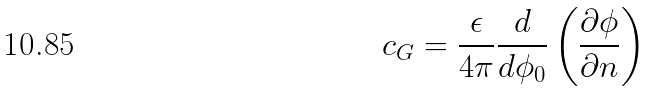Convert formula to latex. <formula><loc_0><loc_0><loc_500><loc_500>c _ { G } = \frac { \epsilon } { 4 \pi } \frac { d } { d \phi _ { 0 } } \left ( \frac { \partial \phi } { \partial n } \right )</formula> 